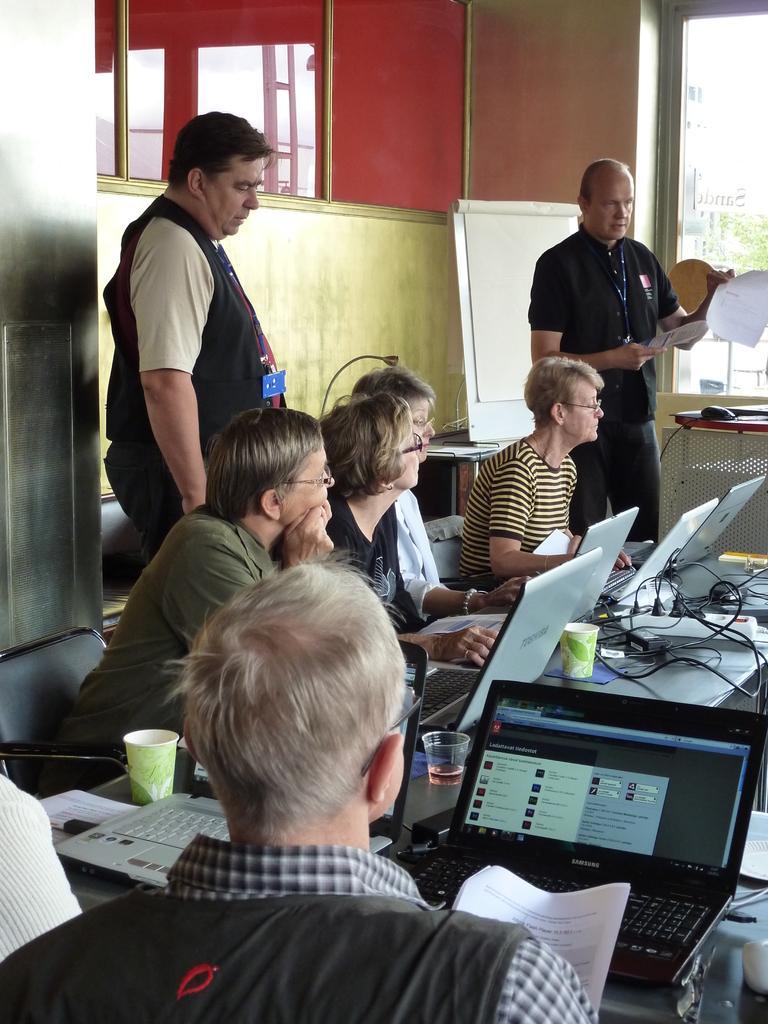In one or two sentences, can you explain what this image depicts? This is the picture where we have group of people sitting on the chairs in front of the table on which there are some systems and glasses and two people standing behind them. 